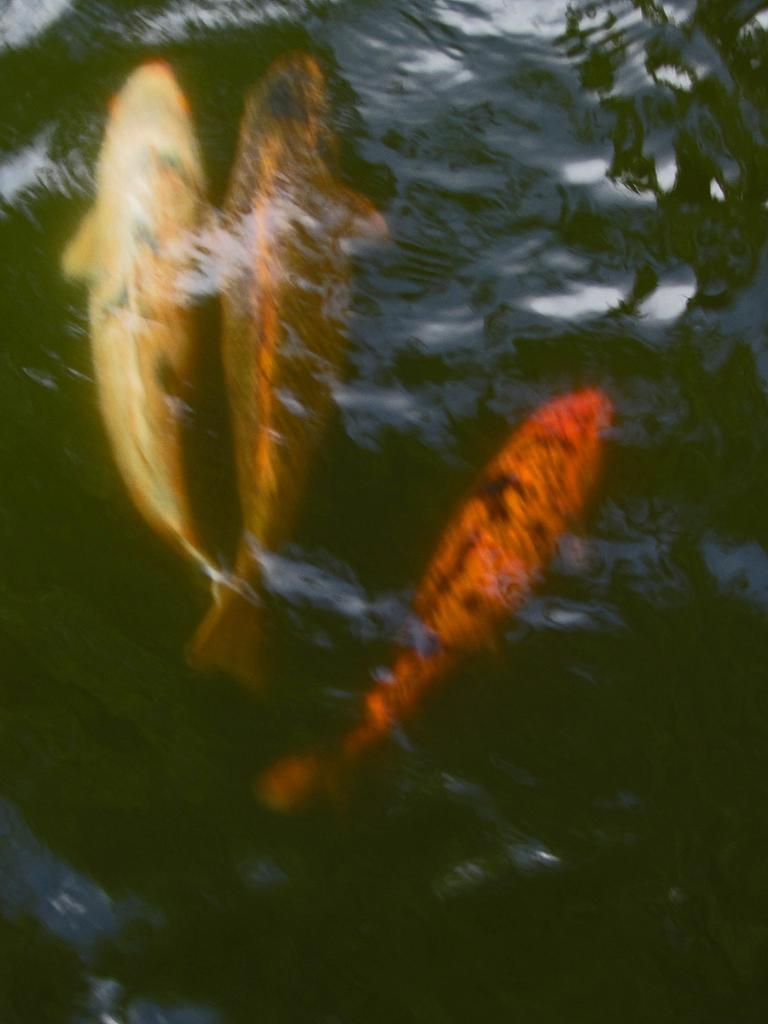How many fishes can be seen in the image? There are three fishes in the image. What are the fishes doing in the image? The fishes are swimming in the water. What type of cream is being applied to the mom's finger in the image? There is no cream or mom present in the image; it features three fishes swimming in the water. 